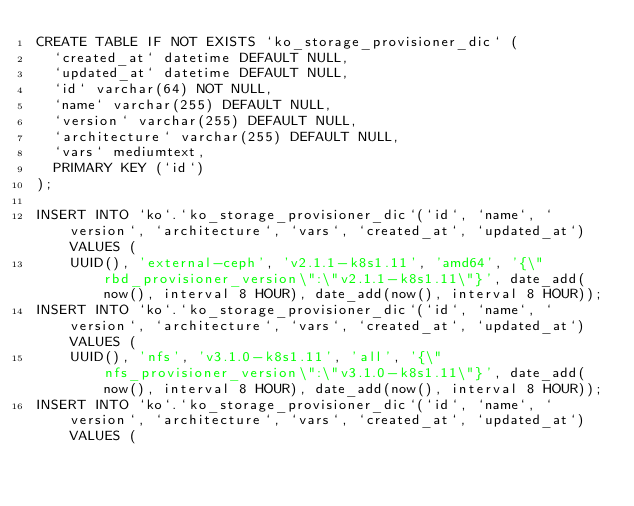<code> <loc_0><loc_0><loc_500><loc_500><_SQL_>CREATE TABLE IF NOT EXISTS `ko_storage_provisioner_dic` (
  `created_at` datetime DEFAULT NULL,
  `updated_at` datetime DEFAULT NULL,
  `id` varchar(64) NOT NULL,
  `name` varchar(255) DEFAULT NULL,
  `version` varchar(255) DEFAULT NULL,
  `architecture` varchar(255) DEFAULT NULL,
  `vars` mediumtext,
  PRIMARY KEY (`id`)
);

INSERT INTO `ko`.`ko_storage_provisioner_dic`(`id`, `name`, `version`, `architecture`, `vars`, `created_at`, `updated_at`) VALUES (
    UUID(), 'external-ceph', 'v2.1.1-k8s1.11', 'amd64', '{\"rbd_provisioner_version\":\"v2.1.1-k8s1.11\"}', date_add(now(), interval 8 HOUR), date_add(now(), interval 8 HOUR));
INSERT INTO `ko`.`ko_storage_provisioner_dic`(`id`, `name`, `version`, `architecture`, `vars`, `created_at`, `updated_at`) VALUES (
    UUID(), 'nfs', 'v3.1.0-k8s1.11', 'all', '{\"nfs_provisioner_version\":\"v3.1.0-k8s1.11\"}', date_add(now(), interval 8 HOUR), date_add(now(), interval 8 HOUR));
INSERT INTO `ko`.`ko_storage_provisioner_dic`(`id`, `name`, `version`, `architecture`, `vars`, `created_at`, `updated_at`) VALUES (</code> 